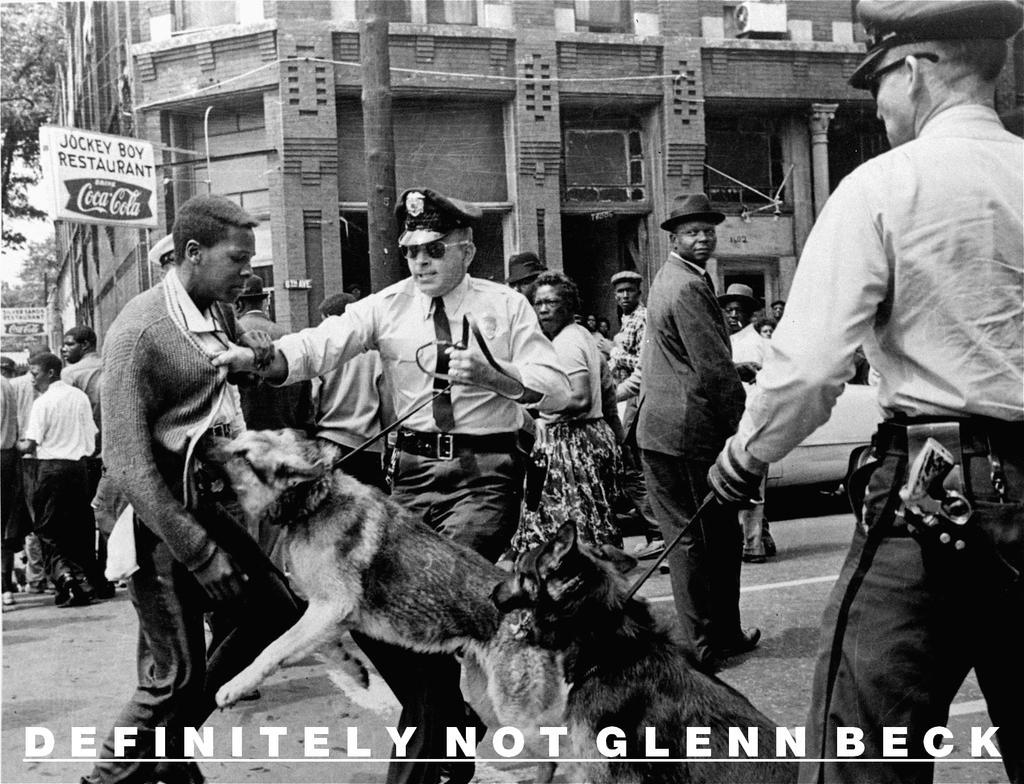Could you give a brief overview of what you see in this image? Two persons wearing caps and goggles are holding dogs with a belt. There are many other persons in this. In the background there is a tree, building, name board. 